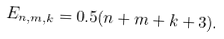Convert formula to latex. <formula><loc_0><loc_0><loc_500><loc_500>E _ { n , m , k } = 0 . 5 ( n + m + k + 3 ) .</formula> 